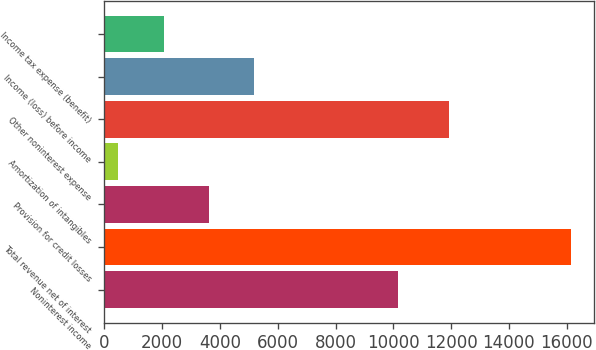Convert chart. <chart><loc_0><loc_0><loc_500><loc_500><bar_chart><fcel>Noninterest income<fcel>Total revenue net of interest<fcel>Provision for credit losses<fcel>Amortization of intangibles<fcel>Other noninterest expense<fcel>Income (loss) before income<fcel>Income tax expense (benefit)<nl><fcel>10149<fcel>16137<fcel>3611.4<fcel>480<fcel>11917<fcel>5177.1<fcel>2045.7<nl></chart> 